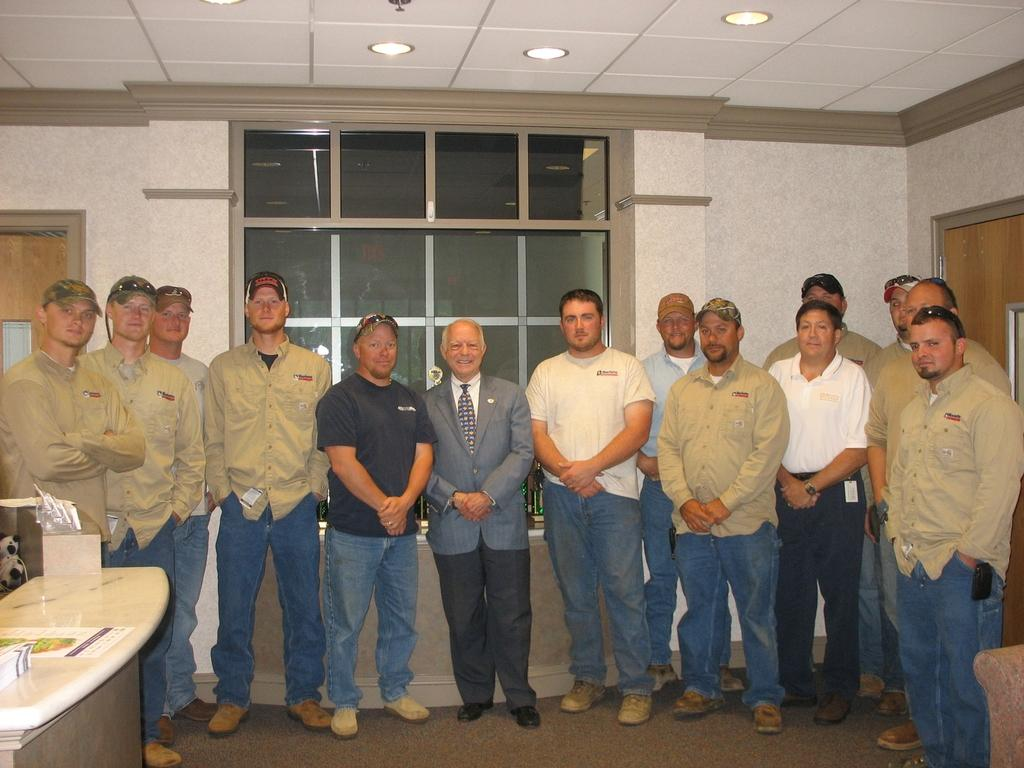What are the people in the image doing? There is a group of people standing in the image. What can be seen in the image besides the people? There is a wooden table in the image. How can you describe the person at the center of the group? The person at the center of the group is laughing. What type of noise is the person at the center of the group making? The person at the center of the group is laughing, but there is no indication of the specific noise they are making. 